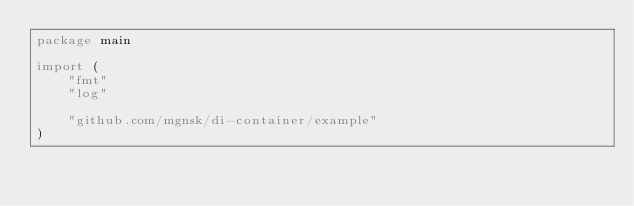<code> <loc_0><loc_0><loc_500><loc_500><_Go_>package main

import (
	"fmt"
	"log"

	"github.com/mgnsk/di-container/example"
)
</code> 